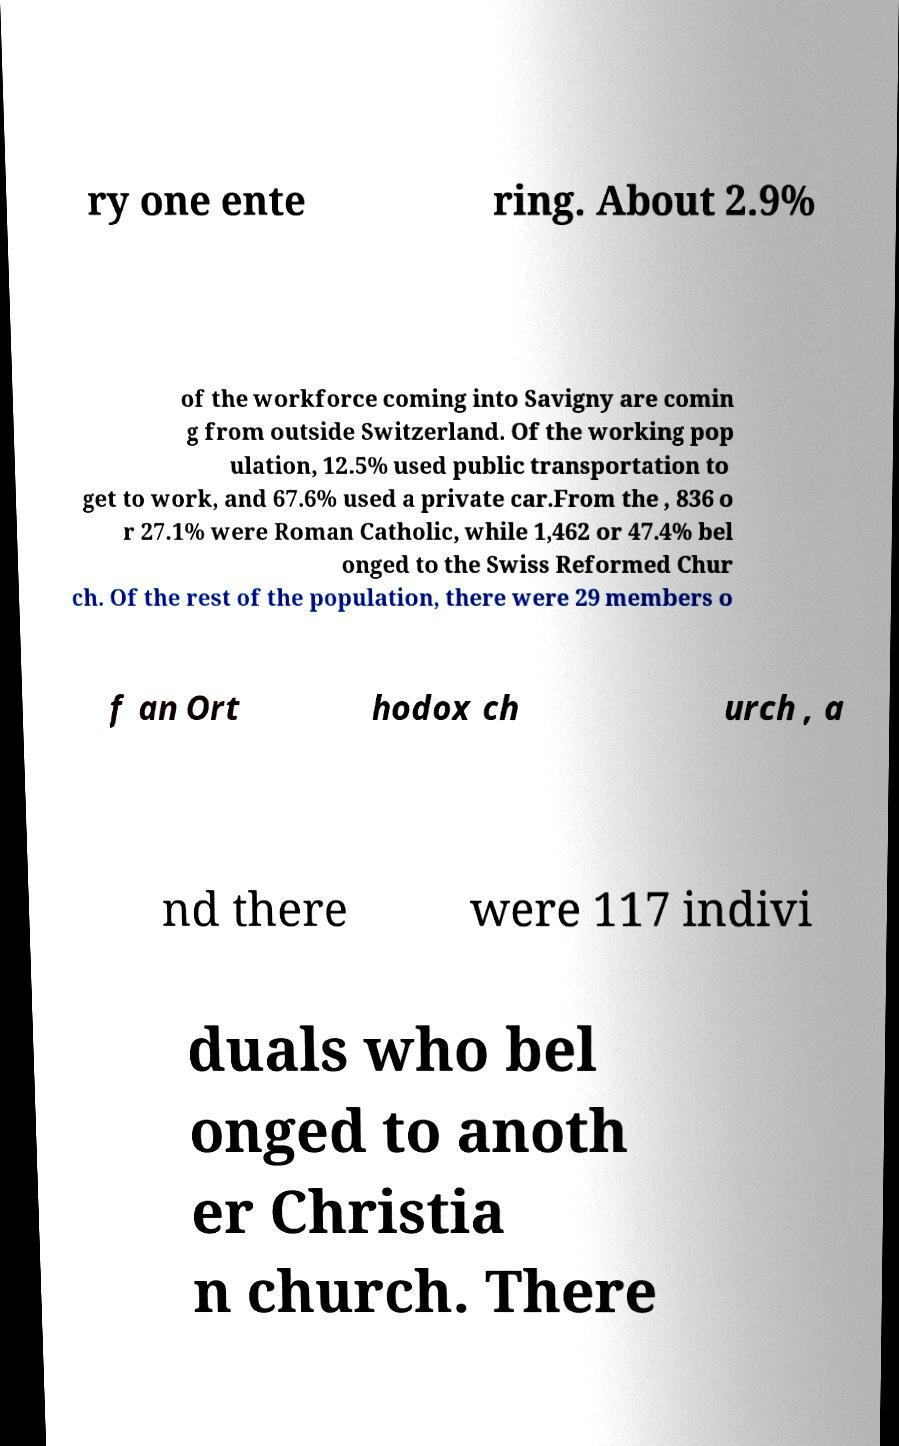Could you extract and type out the text from this image? ry one ente ring. About 2.9% of the workforce coming into Savigny are comin g from outside Switzerland. Of the working pop ulation, 12.5% used public transportation to get to work, and 67.6% used a private car.From the , 836 o r 27.1% were Roman Catholic, while 1,462 or 47.4% bel onged to the Swiss Reformed Chur ch. Of the rest of the population, there were 29 members o f an Ort hodox ch urch , a nd there were 117 indivi duals who bel onged to anoth er Christia n church. There 